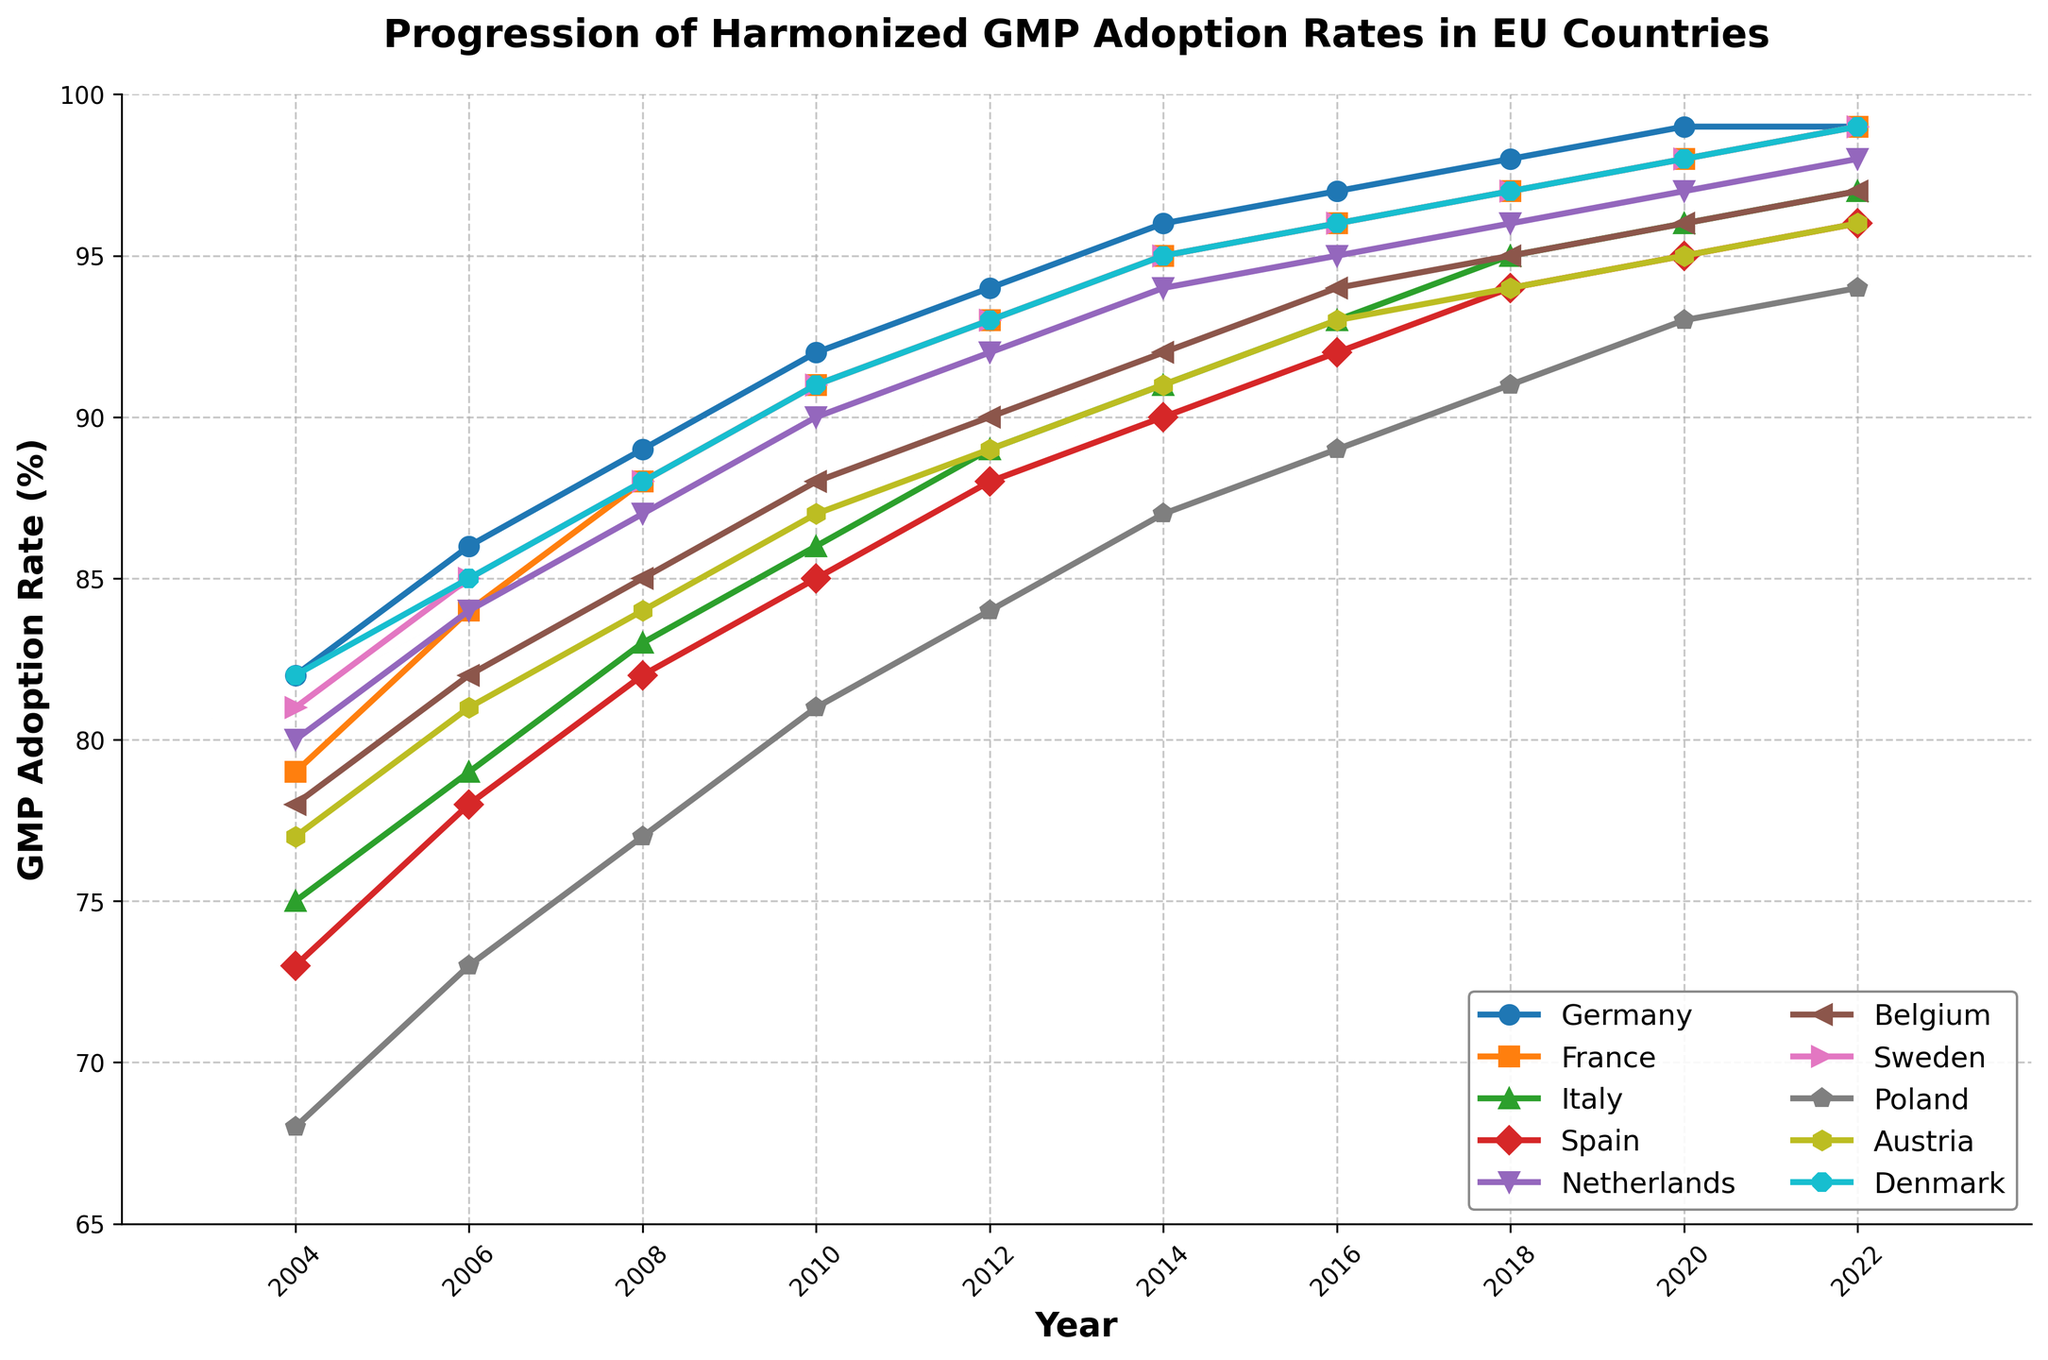What is the overall trend of GMP adoption rates among EU countries from 2004 to 2022? The overall trend shows a gradual increase in GMP adoption rates among EU countries. This can be observed by noting that the lines for each country move upward from 2004 to 2022.
Answer: Increasing Which country had the highest GMP adoption rate in 2004, and what was the value? In 2004, Denmark and Germany both had the highest GMP adoption rate. This can be confirmed by looking at the data points for 2004 where Denmark and Germany are both at 82%.
Answer: Denmark and Germany, 82% What is the difference in GMP adoption rates between Italy and Poland in 2010? In 2010, the GMP adoption rate for Italy was 86% and for Poland was 81%. The difference is calculated as 86% - 81% = 5%.
Answer: 5% Which country showed the biggest improvement in GMP adoption rates from 2004 to 2022? Comparing the data points from 2004 and 2022 for each country, Poland exhibited the biggest improvement. In 2004, Poland had a GMP adoption rate of 68% which increased to 94% in 2022, an improvement of 26%.
Answer: Poland Is there any country where the GMP adoption rate remained the same in any two consecutive years? By examining the lines for each country, it can be noticed that Germany's GMP adoption rate remained the same at 99% from 2020 to 2022.
Answer: Germany What is the average GMP adoption rate for Belgium throughout the years? Summing the adoption rates for Belgium from 2004 to 2022 (78 + 82 + 85 + 88 + 90 + 92 + 94 + 95 + 96 + 97) = 897. There are 10 data points, so the average is 897 / 10 = 89.7%.
Answer: 89.7% Which country had the second-highest GMP adoption rate in 2016, and what was the value? In 2016, the highest adoption rate was for Germany at 97%. The second-highest was for Sweden at 96%. By locating the respective data points on the figure, this can be confirmed.
Answer: Sweden, 96% What is the median GMP adoption rate for Spain in the years presented? Listing the GMP adoption rates for Spain (73, 78, 82, 85, 88, 90, 92, 94, 95, 96), the median is the middle value, which, in this sorted list, is 88 (with an even number of values, it's the average of the two middlemost values, 88 and 90).
Answer: 88 